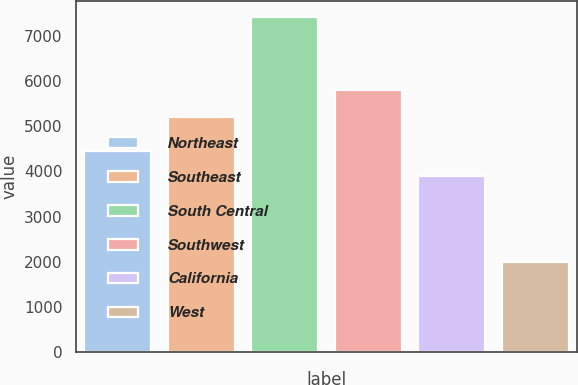<chart> <loc_0><loc_0><loc_500><loc_500><bar_chart><fcel>Northeast<fcel>Southeast<fcel>South Central<fcel>Southwest<fcel>California<fcel>West<nl><fcel>4440<fcel>5200<fcel>7400<fcel>5800<fcel>3900<fcel>2000<nl></chart> 